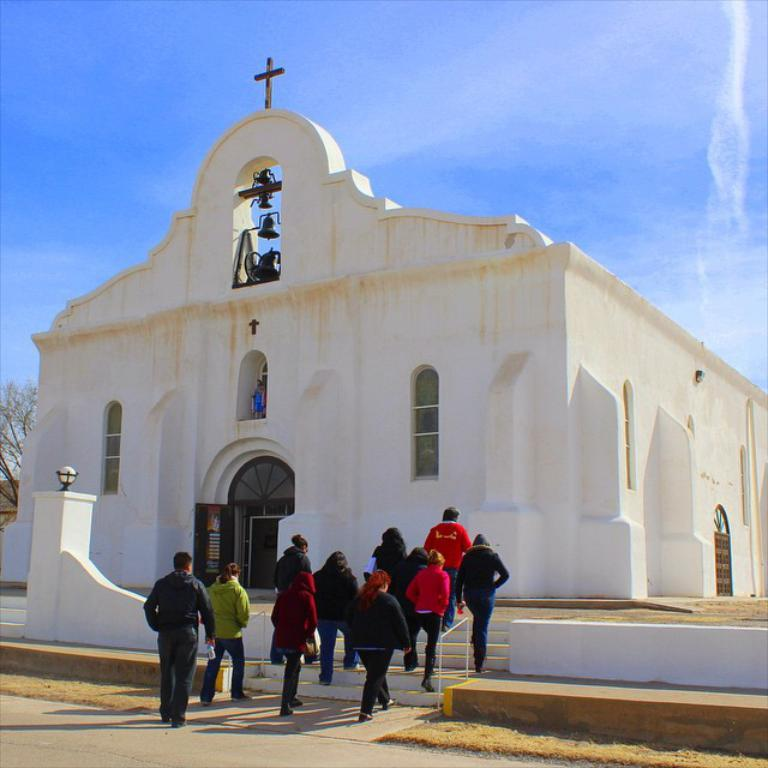What type of structure is present in the image? There is a building in the image. What object can be seen hanging near the building? There is a bell in the image. What are the people in the image doing? There are people walking in the image. Can you describe the lighting conditions in the image? There is light visible in the image. What type of vegetation is present in the image? There is a tree in the image. What part of the natural environment is visible in the image? The sky is visible in the image. What type of sun is depicted in the picture? There is no sun depicted in the image; it only shows a building, a bell, people walking, light, a tree, and the sky. What is the top of the building made of in the image? The provided facts do not mention the material or construction of the building's top. 